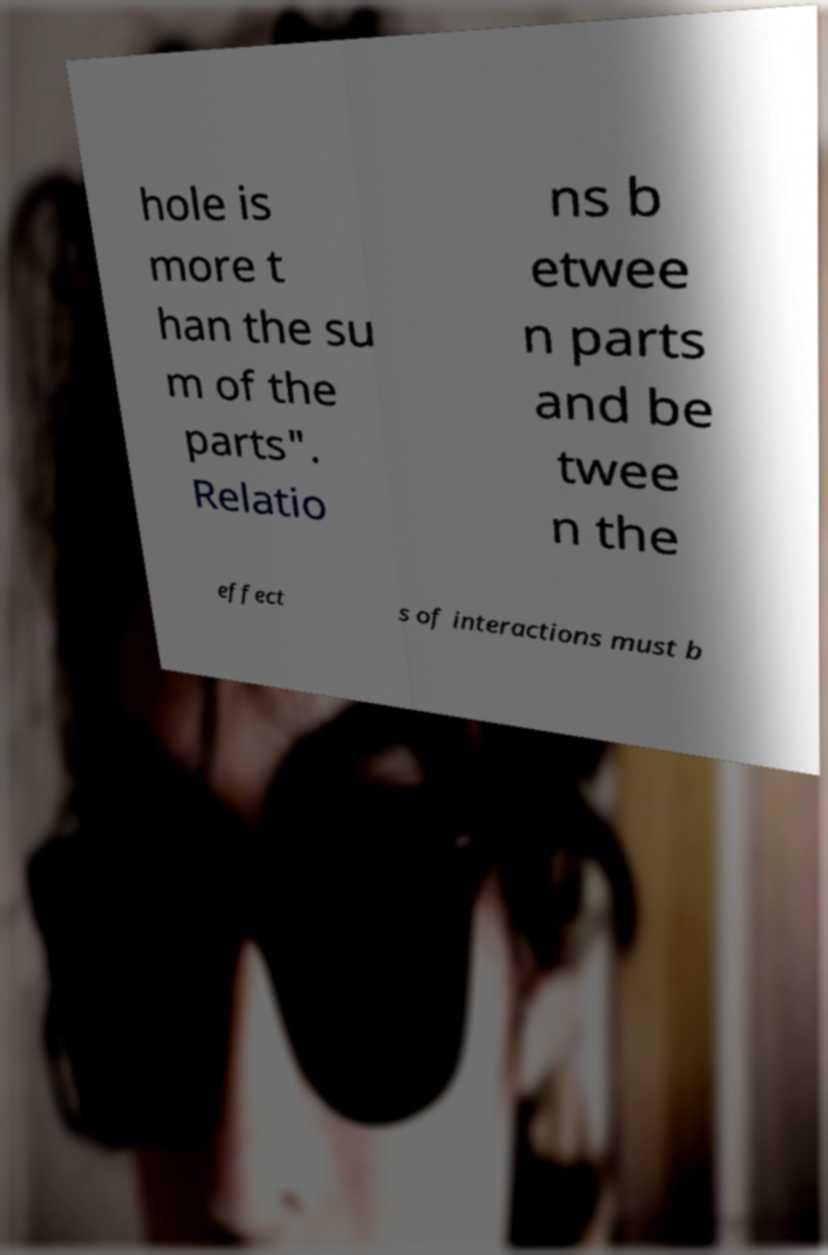What messages or text are displayed in this image? I need them in a readable, typed format. hole is more t han the su m of the parts". Relatio ns b etwee n parts and be twee n the effect s of interactions must b 